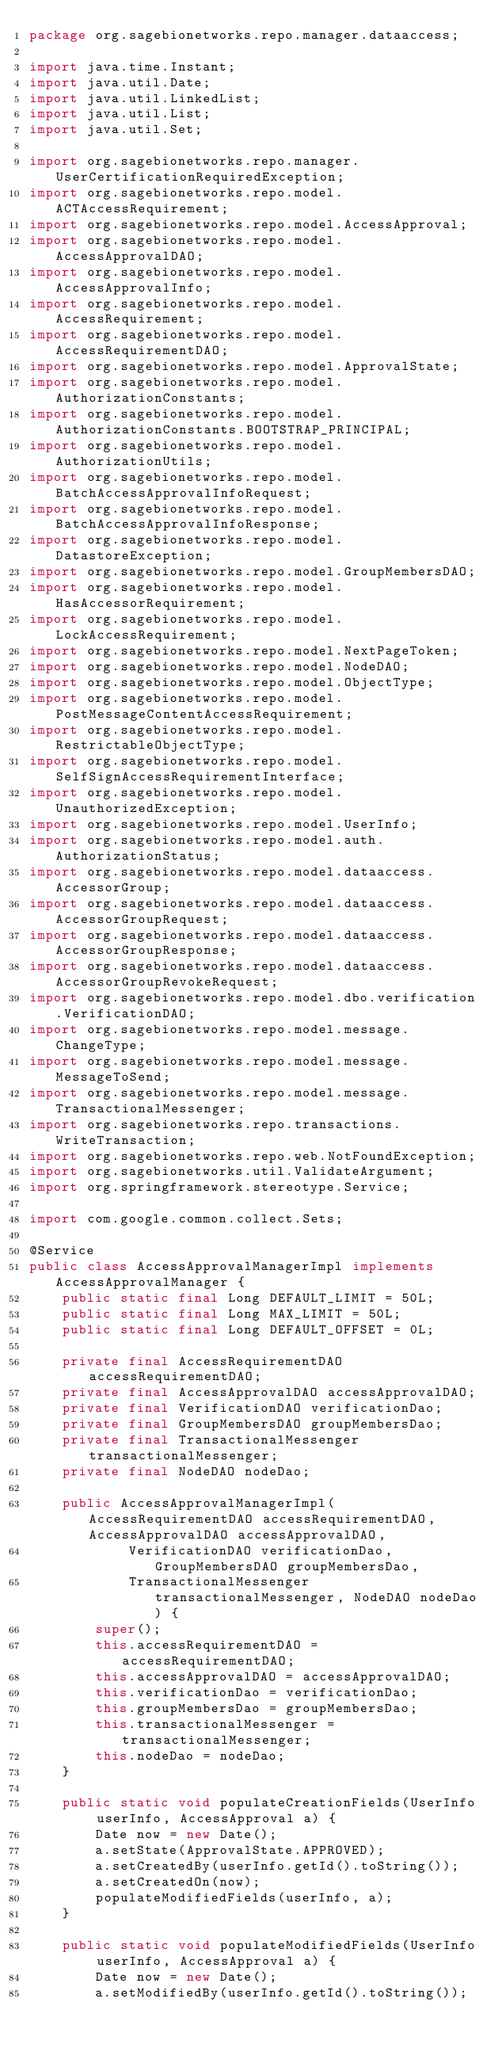<code> <loc_0><loc_0><loc_500><loc_500><_Java_>package org.sagebionetworks.repo.manager.dataaccess;

import java.time.Instant;
import java.util.Date;
import java.util.LinkedList;
import java.util.List;
import java.util.Set;

import org.sagebionetworks.repo.manager.UserCertificationRequiredException;
import org.sagebionetworks.repo.model.ACTAccessRequirement;
import org.sagebionetworks.repo.model.AccessApproval;
import org.sagebionetworks.repo.model.AccessApprovalDAO;
import org.sagebionetworks.repo.model.AccessApprovalInfo;
import org.sagebionetworks.repo.model.AccessRequirement;
import org.sagebionetworks.repo.model.AccessRequirementDAO;
import org.sagebionetworks.repo.model.ApprovalState;
import org.sagebionetworks.repo.model.AuthorizationConstants;
import org.sagebionetworks.repo.model.AuthorizationConstants.BOOTSTRAP_PRINCIPAL;
import org.sagebionetworks.repo.model.AuthorizationUtils;
import org.sagebionetworks.repo.model.BatchAccessApprovalInfoRequest;
import org.sagebionetworks.repo.model.BatchAccessApprovalInfoResponse;
import org.sagebionetworks.repo.model.DatastoreException;
import org.sagebionetworks.repo.model.GroupMembersDAO;
import org.sagebionetworks.repo.model.HasAccessorRequirement;
import org.sagebionetworks.repo.model.LockAccessRequirement;
import org.sagebionetworks.repo.model.NextPageToken;
import org.sagebionetworks.repo.model.NodeDAO;
import org.sagebionetworks.repo.model.ObjectType;
import org.sagebionetworks.repo.model.PostMessageContentAccessRequirement;
import org.sagebionetworks.repo.model.RestrictableObjectType;
import org.sagebionetworks.repo.model.SelfSignAccessRequirementInterface;
import org.sagebionetworks.repo.model.UnauthorizedException;
import org.sagebionetworks.repo.model.UserInfo;
import org.sagebionetworks.repo.model.auth.AuthorizationStatus;
import org.sagebionetworks.repo.model.dataaccess.AccessorGroup;
import org.sagebionetworks.repo.model.dataaccess.AccessorGroupRequest;
import org.sagebionetworks.repo.model.dataaccess.AccessorGroupResponse;
import org.sagebionetworks.repo.model.dataaccess.AccessorGroupRevokeRequest;
import org.sagebionetworks.repo.model.dbo.verification.VerificationDAO;
import org.sagebionetworks.repo.model.message.ChangeType;
import org.sagebionetworks.repo.model.message.MessageToSend;
import org.sagebionetworks.repo.model.message.TransactionalMessenger;
import org.sagebionetworks.repo.transactions.WriteTransaction;
import org.sagebionetworks.repo.web.NotFoundException;
import org.sagebionetworks.util.ValidateArgument;
import org.springframework.stereotype.Service;

import com.google.common.collect.Sets;

@Service
public class AccessApprovalManagerImpl implements AccessApprovalManager {
	public static final Long DEFAULT_LIMIT = 50L;
	public static final Long MAX_LIMIT = 50L;
	public static final Long DEFAULT_OFFSET = 0L;
	
	private final AccessRequirementDAO accessRequirementDAO;
	private final AccessApprovalDAO accessApprovalDAO;
	private final VerificationDAO verificationDao;
	private final GroupMembersDAO groupMembersDao;
	private final TransactionalMessenger transactionalMessenger;
	private final NodeDAO nodeDao;
	
	public AccessApprovalManagerImpl(AccessRequirementDAO accessRequirementDAO, AccessApprovalDAO accessApprovalDAO,
			VerificationDAO verificationDao, GroupMembersDAO groupMembersDao,
			TransactionalMessenger transactionalMessenger, NodeDAO nodeDao) {
		super();
		this.accessRequirementDAO = accessRequirementDAO;
		this.accessApprovalDAO = accessApprovalDAO;
		this.verificationDao = verificationDao;
		this.groupMembersDao = groupMembersDao;
		this.transactionalMessenger = transactionalMessenger;
		this.nodeDao = nodeDao;
	}

	public static void populateCreationFields(UserInfo userInfo, AccessApproval a) {
		Date now = new Date();
		a.setState(ApprovalState.APPROVED);
		a.setCreatedBy(userInfo.getId().toString());
		a.setCreatedOn(now);
		populateModifiedFields(userInfo, a);
	}

	public static void populateModifiedFields(UserInfo userInfo, AccessApproval a) {
		Date now = new Date();
		a.setModifiedBy(userInfo.getId().toString());</code> 